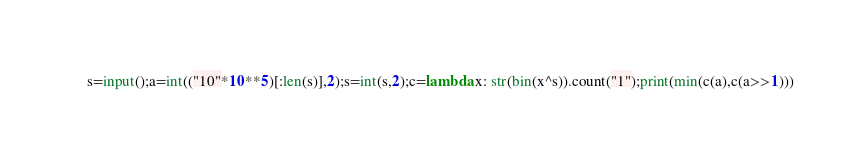Convert code to text. <code><loc_0><loc_0><loc_500><loc_500><_Python_>s=input();a=int(("10"*10**5)[:len(s)],2);s=int(s,2);c=lambda x: str(bin(x^s)).count("1");print(min(c(a),c(a>>1)))</code> 